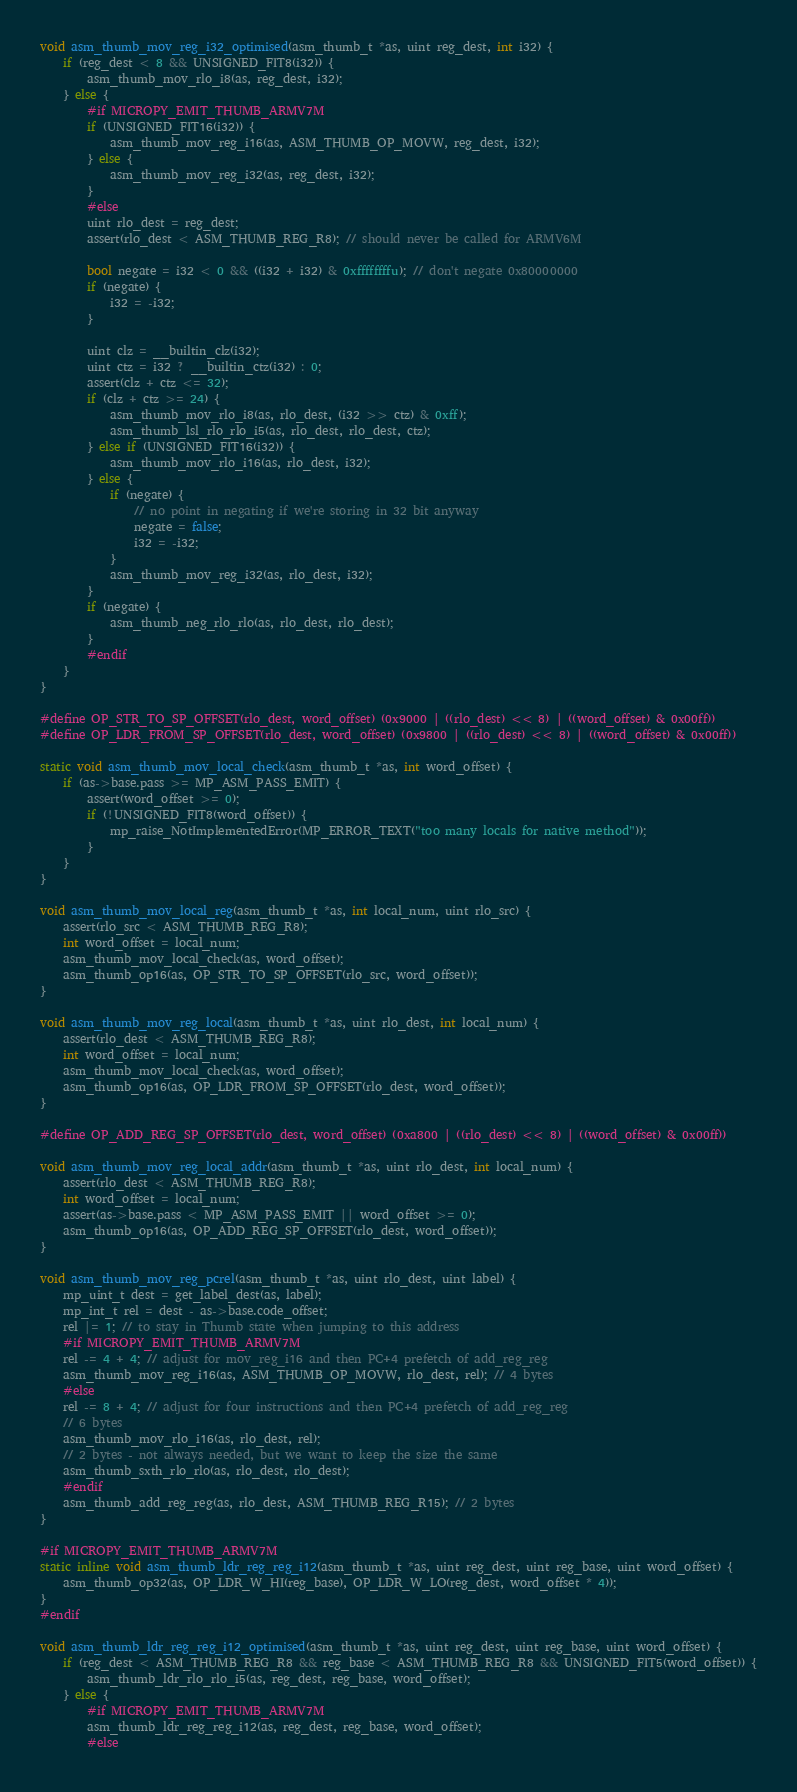Convert code to text. <code><loc_0><loc_0><loc_500><loc_500><_C_>
void asm_thumb_mov_reg_i32_optimised(asm_thumb_t *as, uint reg_dest, int i32) {
    if (reg_dest < 8 && UNSIGNED_FIT8(i32)) {
        asm_thumb_mov_rlo_i8(as, reg_dest, i32);
    } else {
        #if MICROPY_EMIT_THUMB_ARMV7M
        if (UNSIGNED_FIT16(i32)) {
            asm_thumb_mov_reg_i16(as, ASM_THUMB_OP_MOVW, reg_dest, i32);
        } else {
            asm_thumb_mov_reg_i32(as, reg_dest, i32);
        }
        #else
        uint rlo_dest = reg_dest;
        assert(rlo_dest < ASM_THUMB_REG_R8); // should never be called for ARMV6M

        bool negate = i32 < 0 && ((i32 + i32) & 0xffffffffu); // don't negate 0x80000000
        if (negate) {
            i32 = -i32;
        }

        uint clz = __builtin_clz(i32);
        uint ctz = i32 ? __builtin_ctz(i32) : 0;
        assert(clz + ctz <= 32);
        if (clz + ctz >= 24) {
            asm_thumb_mov_rlo_i8(as, rlo_dest, (i32 >> ctz) & 0xff);
            asm_thumb_lsl_rlo_rlo_i5(as, rlo_dest, rlo_dest, ctz);
        } else if (UNSIGNED_FIT16(i32)) {
            asm_thumb_mov_rlo_i16(as, rlo_dest, i32);
        } else {
            if (negate) {
                // no point in negating if we're storing in 32 bit anyway
                negate = false;
                i32 = -i32;
            }
            asm_thumb_mov_reg_i32(as, rlo_dest, i32);
        }
        if (negate) {
            asm_thumb_neg_rlo_rlo(as, rlo_dest, rlo_dest);
        }
        #endif
    }
}

#define OP_STR_TO_SP_OFFSET(rlo_dest, word_offset) (0x9000 | ((rlo_dest) << 8) | ((word_offset) & 0x00ff))
#define OP_LDR_FROM_SP_OFFSET(rlo_dest, word_offset) (0x9800 | ((rlo_dest) << 8) | ((word_offset) & 0x00ff))

static void asm_thumb_mov_local_check(asm_thumb_t *as, int word_offset) {
    if (as->base.pass >= MP_ASM_PASS_EMIT) {
        assert(word_offset >= 0);
        if (!UNSIGNED_FIT8(word_offset)) {
            mp_raise_NotImplementedError(MP_ERROR_TEXT("too many locals for native method"));
        }
    }
}

void asm_thumb_mov_local_reg(asm_thumb_t *as, int local_num, uint rlo_src) {
    assert(rlo_src < ASM_THUMB_REG_R8);
    int word_offset = local_num;
    asm_thumb_mov_local_check(as, word_offset);
    asm_thumb_op16(as, OP_STR_TO_SP_OFFSET(rlo_src, word_offset));
}

void asm_thumb_mov_reg_local(asm_thumb_t *as, uint rlo_dest, int local_num) {
    assert(rlo_dest < ASM_THUMB_REG_R8);
    int word_offset = local_num;
    asm_thumb_mov_local_check(as, word_offset);
    asm_thumb_op16(as, OP_LDR_FROM_SP_OFFSET(rlo_dest, word_offset));
}

#define OP_ADD_REG_SP_OFFSET(rlo_dest, word_offset) (0xa800 | ((rlo_dest) << 8) | ((word_offset) & 0x00ff))

void asm_thumb_mov_reg_local_addr(asm_thumb_t *as, uint rlo_dest, int local_num) {
    assert(rlo_dest < ASM_THUMB_REG_R8);
    int word_offset = local_num;
    assert(as->base.pass < MP_ASM_PASS_EMIT || word_offset >= 0);
    asm_thumb_op16(as, OP_ADD_REG_SP_OFFSET(rlo_dest, word_offset));
}

void asm_thumb_mov_reg_pcrel(asm_thumb_t *as, uint rlo_dest, uint label) {
    mp_uint_t dest = get_label_dest(as, label);
    mp_int_t rel = dest - as->base.code_offset;
    rel |= 1; // to stay in Thumb state when jumping to this address
    #if MICROPY_EMIT_THUMB_ARMV7M
    rel -= 4 + 4; // adjust for mov_reg_i16 and then PC+4 prefetch of add_reg_reg
    asm_thumb_mov_reg_i16(as, ASM_THUMB_OP_MOVW, rlo_dest, rel); // 4 bytes
    #else
    rel -= 8 + 4; // adjust for four instructions and then PC+4 prefetch of add_reg_reg
    // 6 bytes
    asm_thumb_mov_rlo_i16(as, rlo_dest, rel);
    // 2 bytes - not always needed, but we want to keep the size the same
    asm_thumb_sxth_rlo_rlo(as, rlo_dest, rlo_dest);
    #endif
    asm_thumb_add_reg_reg(as, rlo_dest, ASM_THUMB_REG_R15); // 2 bytes
}

#if MICROPY_EMIT_THUMB_ARMV7M
static inline void asm_thumb_ldr_reg_reg_i12(asm_thumb_t *as, uint reg_dest, uint reg_base, uint word_offset) {
    asm_thumb_op32(as, OP_LDR_W_HI(reg_base), OP_LDR_W_LO(reg_dest, word_offset * 4));
}
#endif

void asm_thumb_ldr_reg_reg_i12_optimised(asm_thumb_t *as, uint reg_dest, uint reg_base, uint word_offset) {
    if (reg_dest < ASM_THUMB_REG_R8 && reg_base < ASM_THUMB_REG_R8 && UNSIGNED_FIT5(word_offset)) {
        asm_thumb_ldr_rlo_rlo_i5(as, reg_dest, reg_base, word_offset);
    } else {
        #if MICROPY_EMIT_THUMB_ARMV7M
        asm_thumb_ldr_reg_reg_i12(as, reg_dest, reg_base, word_offset);
        #else</code> 